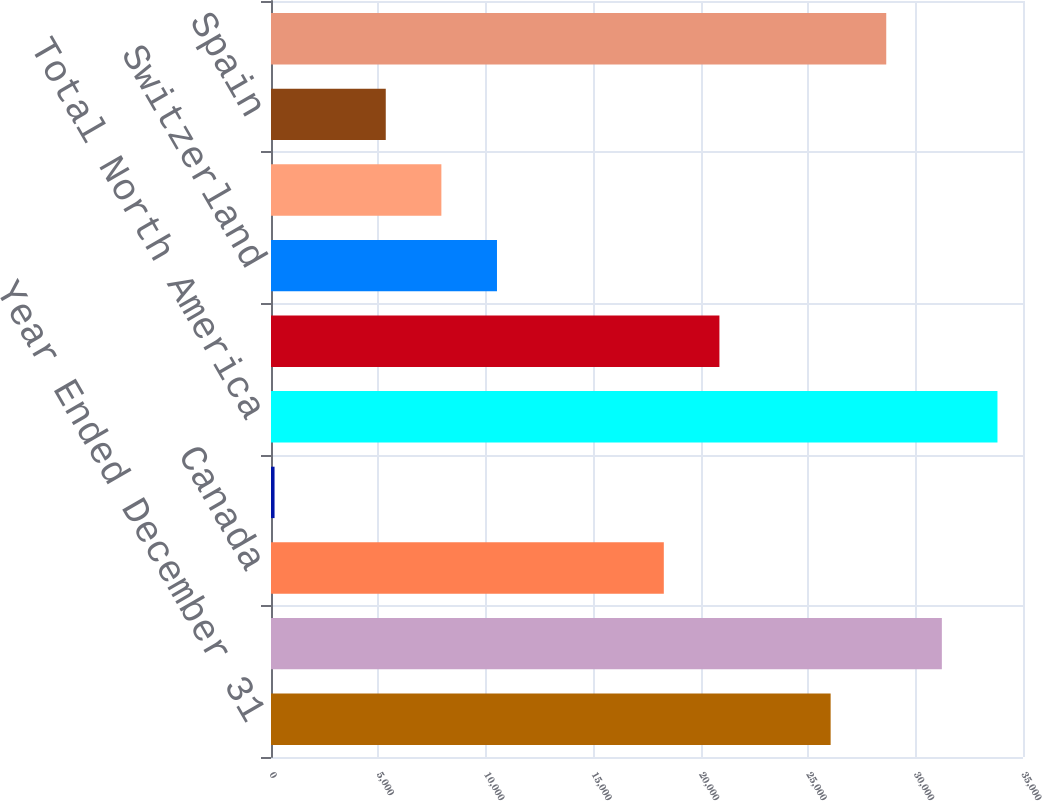<chart> <loc_0><loc_0><loc_500><loc_500><bar_chart><fcel>Year Ended December 31<fcel>United States<fcel>Canada<fcel>Other<fcel>Total North America<fcel>United Kingdom<fcel>Switzerland<fcel>Russia<fcel>Spain<fcel>Total Europe<nl><fcel>26047<fcel>31223.4<fcel>18282.4<fcel>165<fcel>33811.6<fcel>20870.6<fcel>10517.8<fcel>7929.6<fcel>5341.4<fcel>28635.2<nl></chart> 